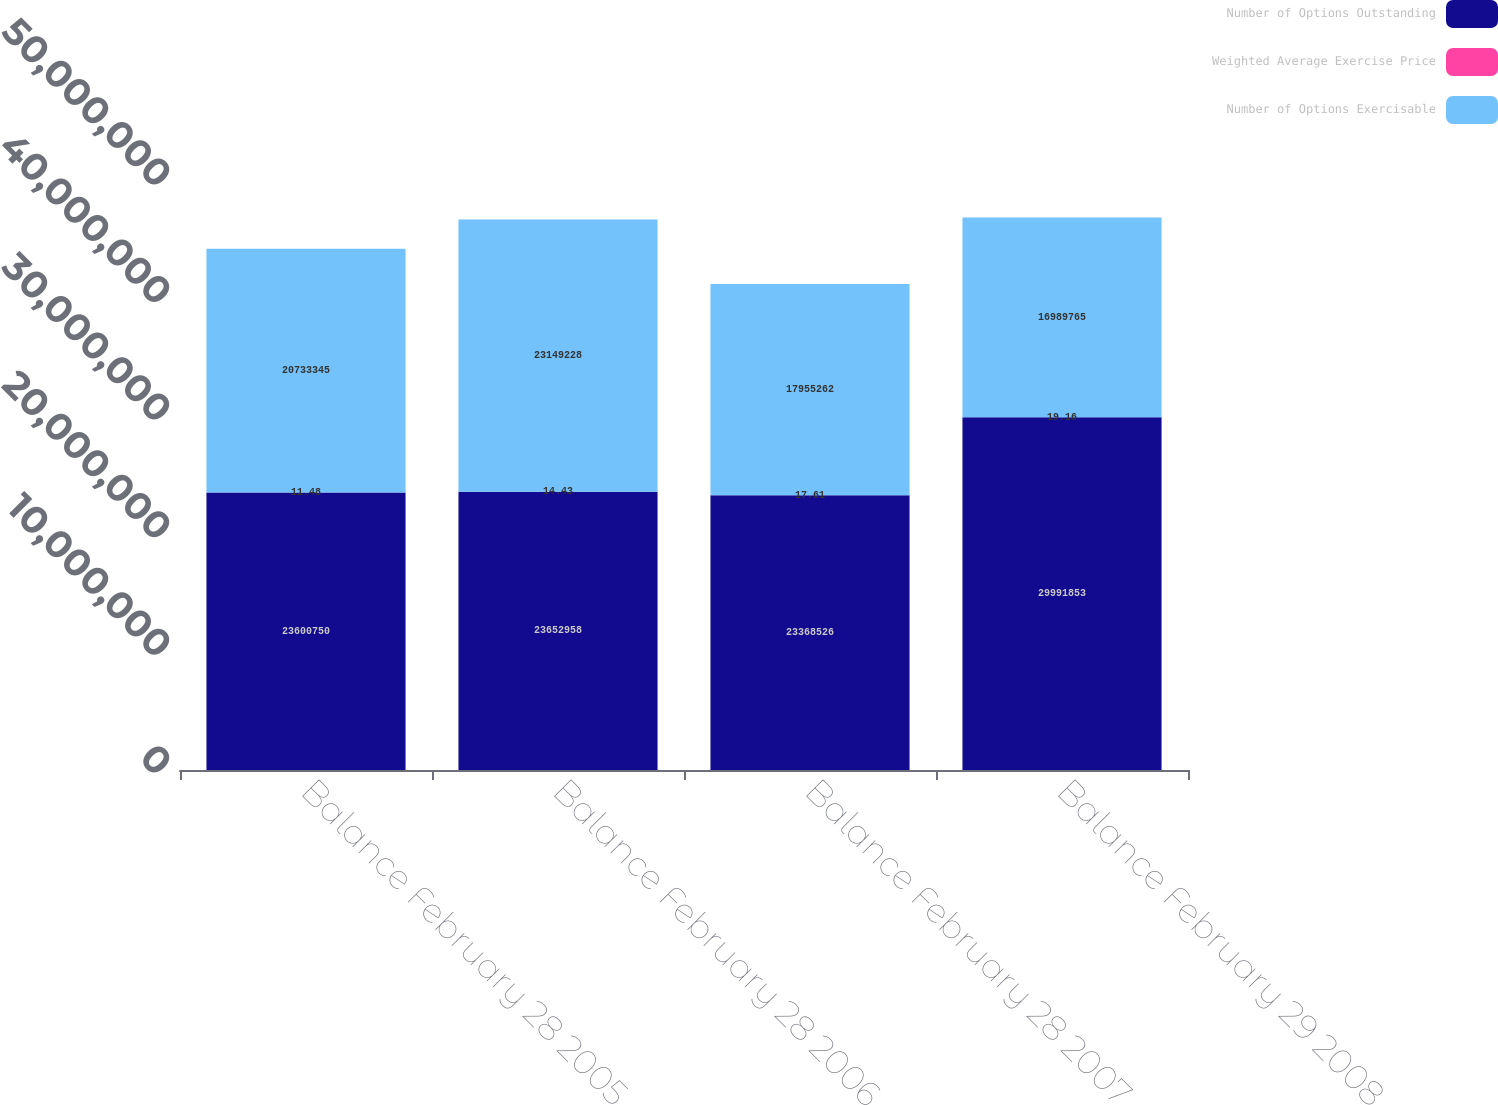Convert chart. <chart><loc_0><loc_0><loc_500><loc_500><stacked_bar_chart><ecel><fcel>Balance February 28 2005<fcel>Balance February 28 2006<fcel>Balance February 28 2007<fcel>Balance February 29 2008<nl><fcel>Number of Options Outstanding<fcel>2.36008e+07<fcel>2.3653e+07<fcel>2.33685e+07<fcel>2.99919e+07<nl><fcel>Weighted Average Exercise Price<fcel>11.48<fcel>14.43<fcel>17.61<fcel>19.16<nl><fcel>Number of Options Exercisable<fcel>2.07333e+07<fcel>2.31492e+07<fcel>1.79553e+07<fcel>1.69898e+07<nl></chart> 